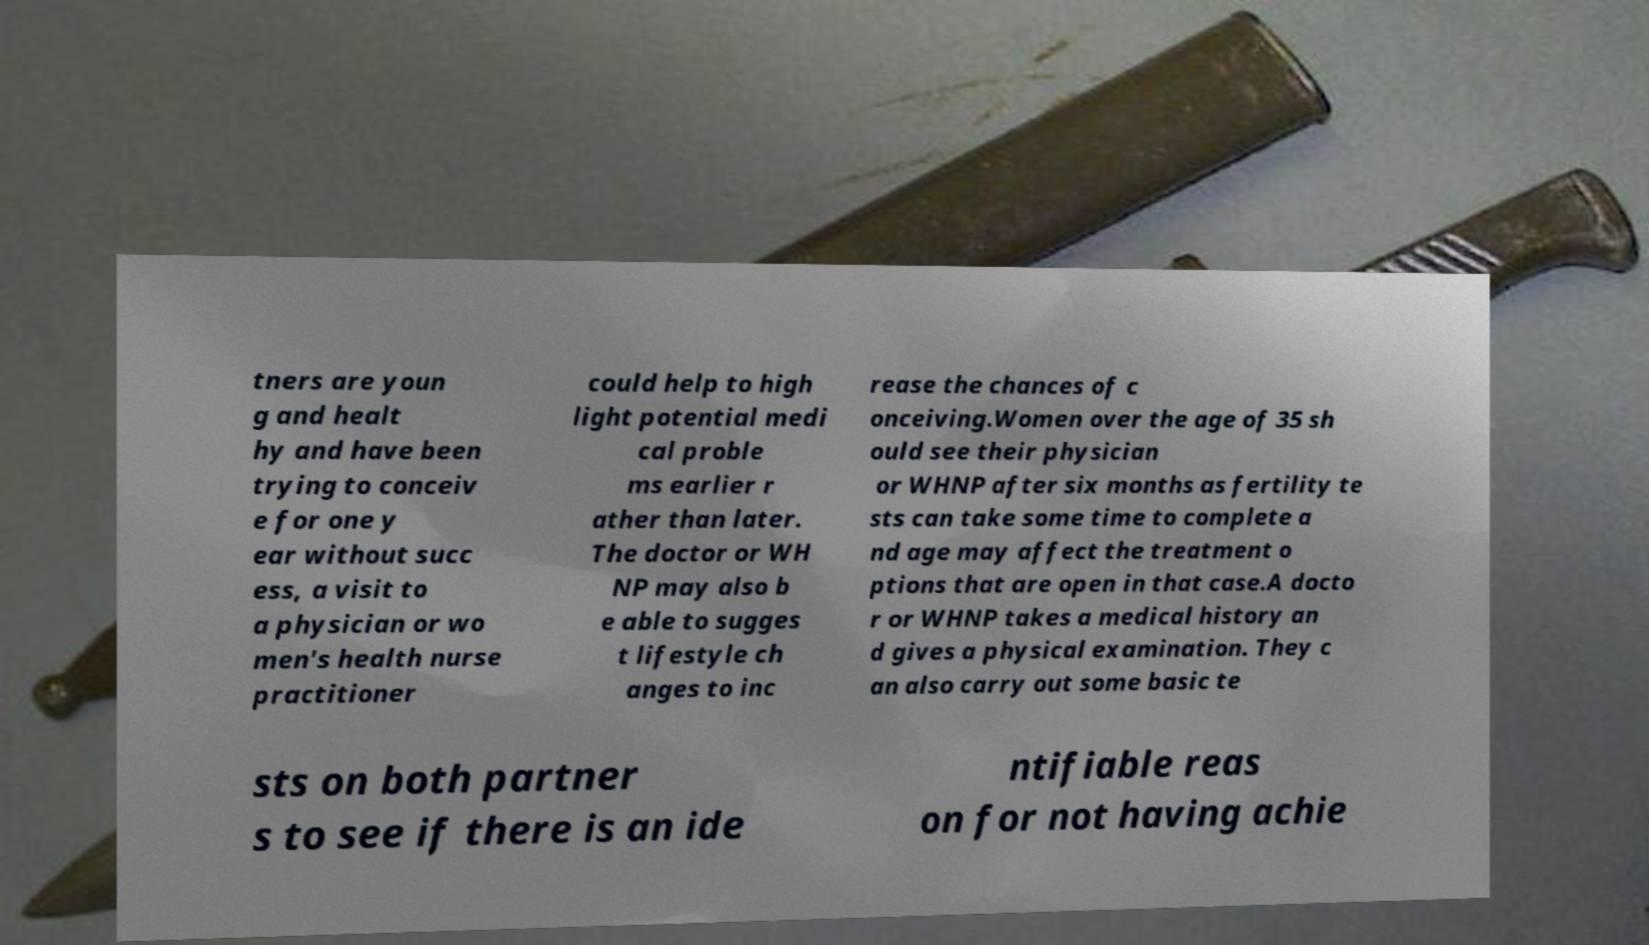Could you assist in decoding the text presented in this image and type it out clearly? tners are youn g and healt hy and have been trying to conceiv e for one y ear without succ ess, a visit to a physician or wo men's health nurse practitioner could help to high light potential medi cal proble ms earlier r ather than later. The doctor or WH NP may also b e able to sugges t lifestyle ch anges to inc rease the chances of c onceiving.Women over the age of 35 sh ould see their physician or WHNP after six months as fertility te sts can take some time to complete a nd age may affect the treatment o ptions that are open in that case.A docto r or WHNP takes a medical history an d gives a physical examination. They c an also carry out some basic te sts on both partner s to see if there is an ide ntifiable reas on for not having achie 